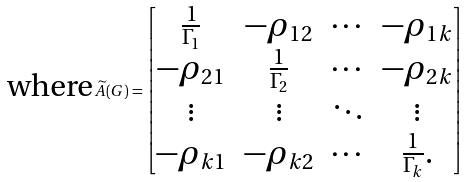Convert formula to latex. <formula><loc_0><loc_0><loc_500><loc_500>\text {where} \, \widetilde { A } ( G ) = \begin{bmatrix} \frac { 1 } { \Gamma _ { 1 } } & - \rho _ { 1 2 } & \cdots & - \rho _ { 1 k } \\ - \rho _ { 2 1 } & \frac { 1 } { \Gamma _ { 2 } } & \cdots & - \rho _ { 2 k } \\ \vdots & \vdots & \ddots & \vdots \\ - \rho _ { k 1 } & - \rho _ { k 2 } & \cdots & \frac { 1 } { \Gamma _ { k } } . \end{bmatrix}</formula> 